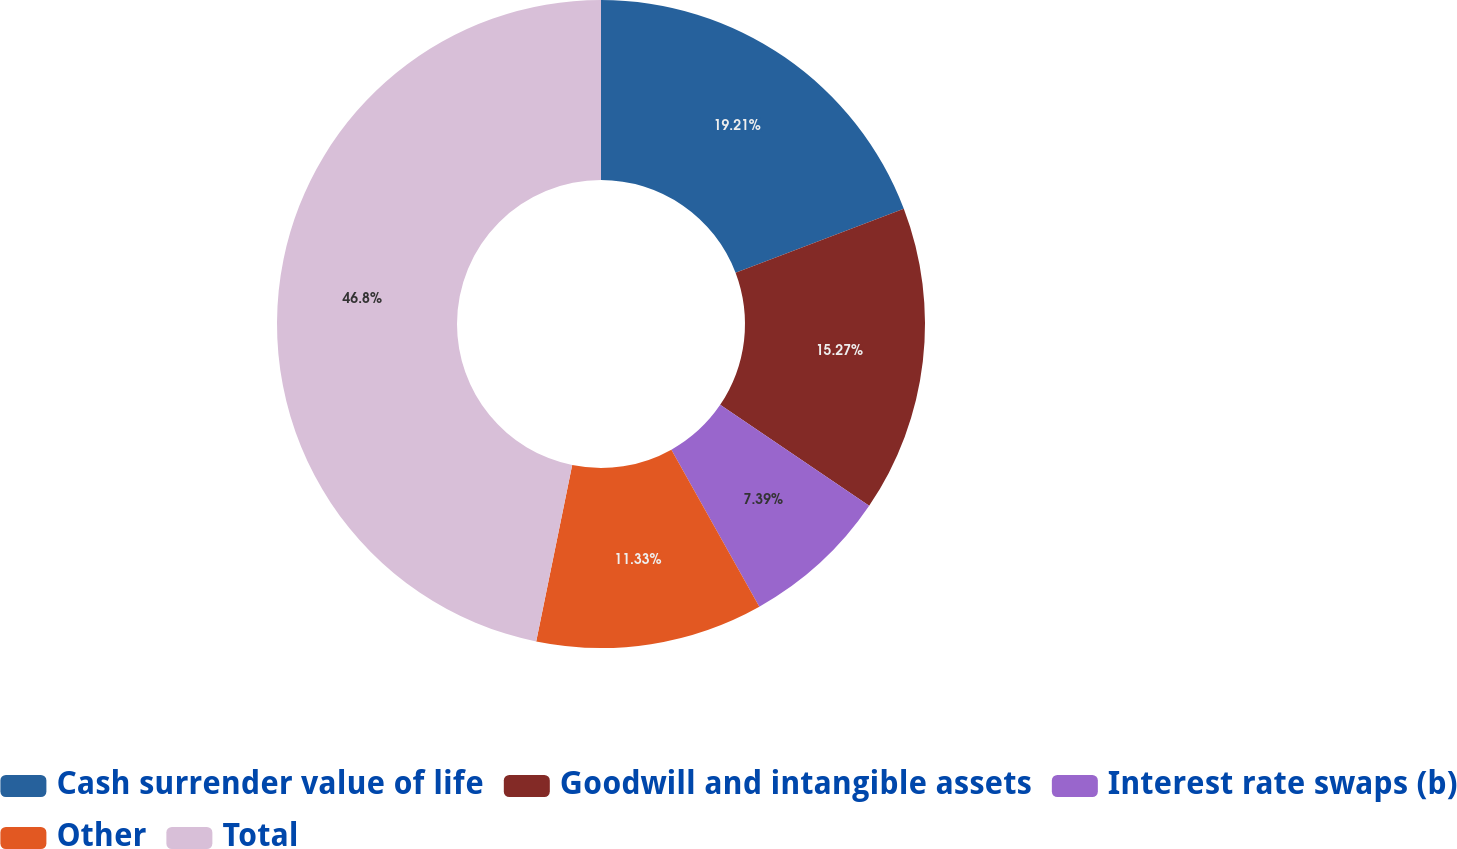Convert chart. <chart><loc_0><loc_0><loc_500><loc_500><pie_chart><fcel>Cash surrender value of life<fcel>Goodwill and intangible assets<fcel>Interest rate swaps (b)<fcel>Other<fcel>Total<nl><fcel>19.21%<fcel>15.27%<fcel>7.39%<fcel>11.33%<fcel>46.79%<nl></chart> 